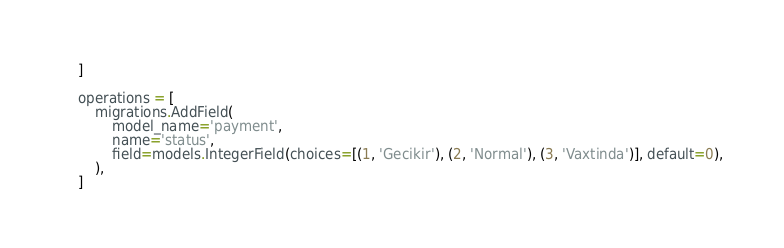<code> <loc_0><loc_0><loc_500><loc_500><_Python_>    ]

    operations = [
        migrations.AddField(
            model_name='payment',
            name='status',
            field=models.IntegerField(choices=[(1, 'Gecikir'), (2, 'Normal'), (3, 'Vaxtinda')], default=0),
        ),
    ]
</code> 